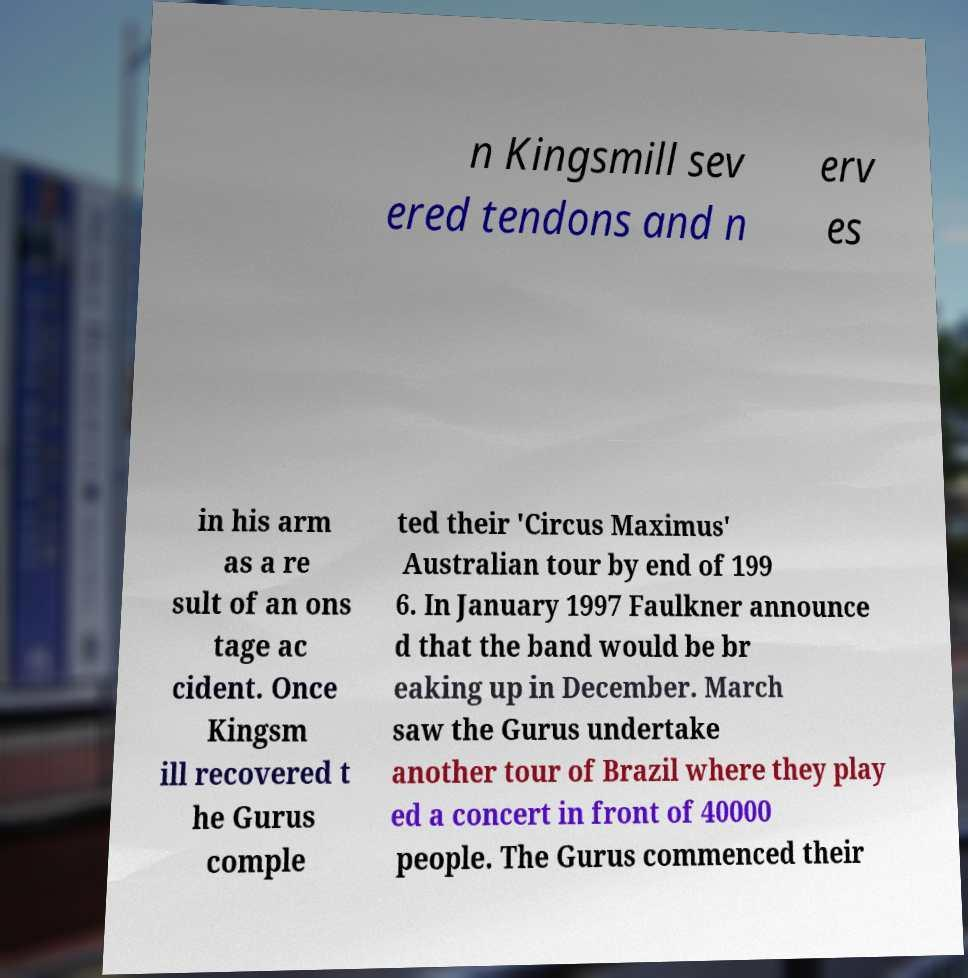Please identify and transcribe the text found in this image. n Kingsmill sev ered tendons and n erv es in his arm as a re sult of an ons tage ac cident. Once Kingsm ill recovered t he Gurus comple ted their 'Circus Maximus' Australian tour by end of 199 6. In January 1997 Faulkner announce d that the band would be br eaking up in December. March saw the Gurus undertake another tour of Brazil where they play ed a concert in front of 40000 people. The Gurus commenced their 